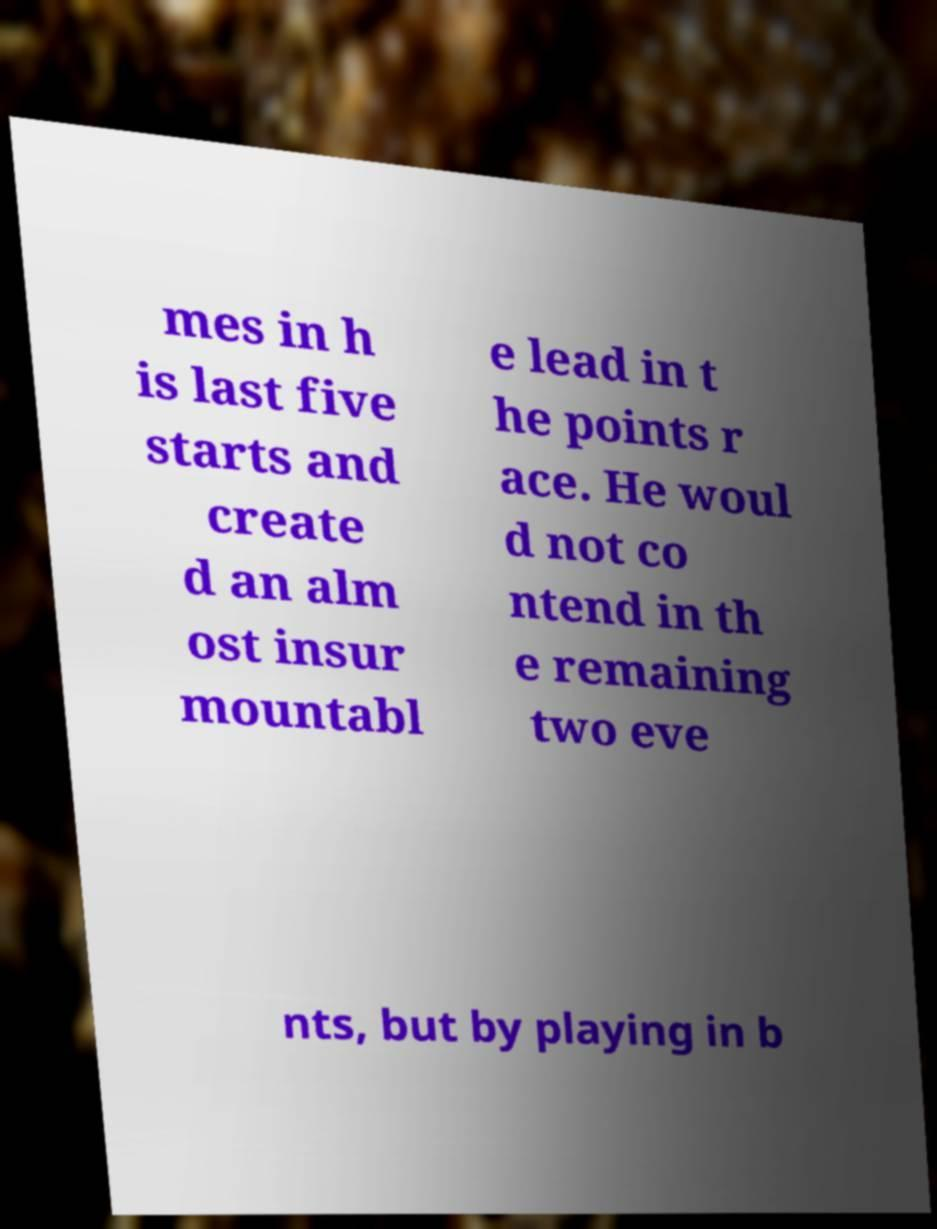What messages or text are displayed in this image? I need them in a readable, typed format. mes in h is last five starts and create d an alm ost insur mountabl e lead in t he points r ace. He woul d not co ntend in th e remaining two eve nts, but by playing in b 